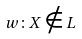Convert formula to latex. <formula><loc_0><loc_0><loc_500><loc_500>w \colon X \notin L</formula> 